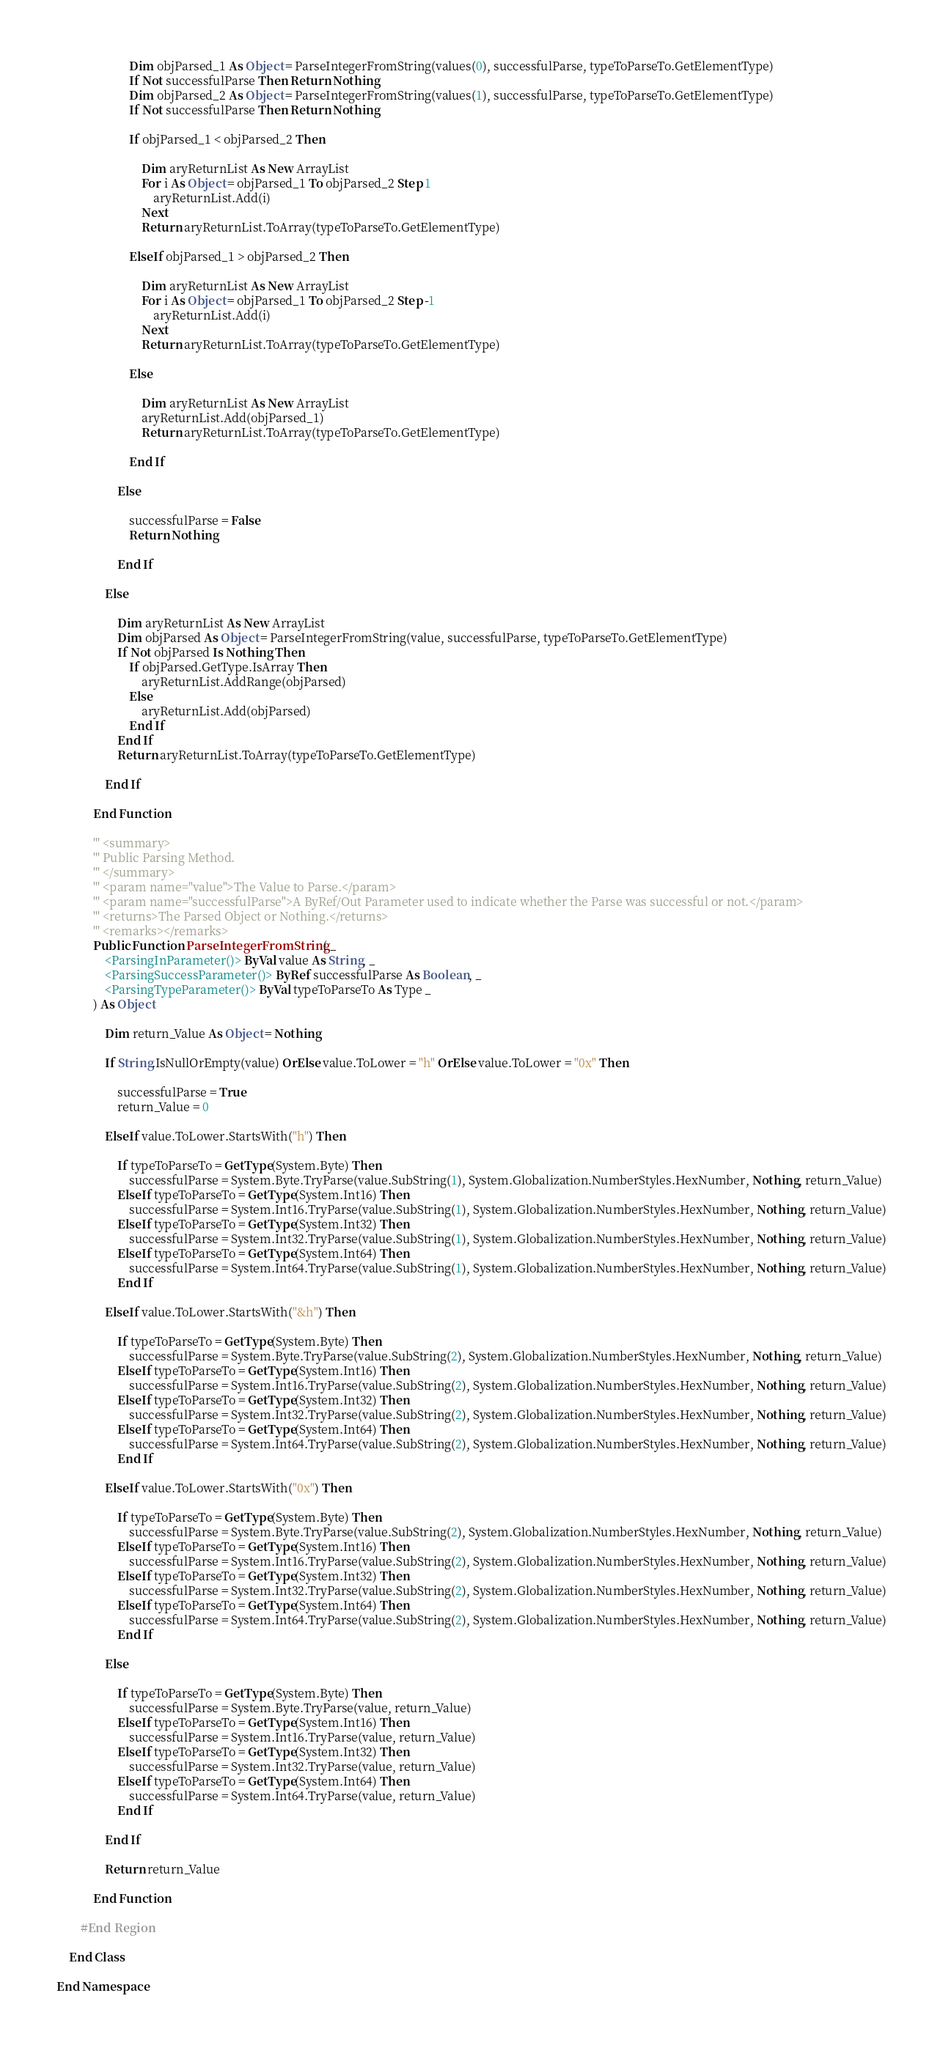<code> <loc_0><loc_0><loc_500><loc_500><_VisualBasic_>
						Dim objParsed_1 As Object = ParseIntegerFromString(values(0), successfulParse, typeToParseTo.GetElementType)
						If Not successfulParse Then Return Nothing
						Dim objParsed_2 As Object = ParseIntegerFromString(values(1), successfulParse, typeToParseTo.GetElementType)
						If Not successfulParse Then Return Nothing

						If objParsed_1 < objParsed_2 Then

							Dim aryReturnList As New ArrayList
							For i As Object = objParsed_1 To objParsed_2 Step 1
								aryReturnList.Add(i)
							Next
							Return aryReturnList.ToArray(typeToParseTo.GetElementType)

						ElseIf objParsed_1 > objParsed_2 Then

							Dim aryReturnList As New ArrayList
							For i As Object = objParsed_1 To objParsed_2 Step -1
								aryReturnList.Add(i)
							Next
							Return aryReturnList.ToArray(typeToParseTo.GetElementType)

						Else

							Dim aryReturnList As New ArrayList
							aryReturnList.Add(objParsed_1)
							Return aryReturnList.ToArray(typeToParseTo.GetElementType)

						End If

					Else

						successfulParse = False
						Return Nothing

					End If

				Else

					Dim aryReturnList As New ArrayList
					Dim objParsed As Object = ParseIntegerFromString(value, successfulParse, typeToParseTo.GetElementType)
					If Not objParsed Is Nothing Then
						If objParsed.GetType.IsArray Then
							aryReturnList.AddRange(objParsed)
						Else
							aryReturnList.Add(objParsed)
						End If
					End If
					Return aryReturnList.ToArray(typeToParseTo.GetElementType)

				End If

			End Function

			''' <summary>
			''' Public Parsing Method.
			''' </summary>
			''' <param name="value">The Value to Parse.</param>
			''' <param name="successfulParse">A ByRef/Out Parameter used to indicate whether the Parse was successful or not.</param>
			''' <returns>The Parsed Object or Nothing.</returns>
			''' <remarks></remarks>
			Public Function ParseIntegerFromString( _
				<ParsingInParameter()> ByVal value As String, _
				<ParsingSuccessParameter()> ByRef successfulParse As Boolean, _
				<ParsingTypeParameter()> ByVal typeToParseTo As Type _
			) As Object

				Dim return_Value As Object = Nothing

				If String.IsNullOrEmpty(value) OrElse value.ToLower = "h" OrElse value.ToLower = "0x" Then

					successfulParse = True
					return_Value = 0

				ElseIf value.ToLower.StartsWith("h") Then

					If typeToParseTo = GetType(System.Byte) Then
						successfulParse = System.Byte.TryParse(value.SubString(1), System.Globalization.NumberStyles.HexNumber, Nothing, return_Value)
					ElseIf typeToParseTo = GetType(System.Int16) Then
						successfulParse = System.Int16.TryParse(value.SubString(1), System.Globalization.NumberStyles.HexNumber, Nothing, return_Value)
					ElseIf typeToParseTo = GetType(System.Int32) Then
						successfulParse = System.Int32.TryParse(value.SubString(1), System.Globalization.NumberStyles.HexNumber, Nothing, return_Value)
					ElseIf typeToParseTo = GetType(System.Int64) Then
						successfulParse = System.Int64.TryParse(value.SubString(1), System.Globalization.NumberStyles.HexNumber, Nothing, return_Value)
					End If

				ElseIf value.ToLower.StartsWith("&h") Then

					If typeToParseTo = GetType(System.Byte) Then
						successfulParse = System.Byte.TryParse(value.SubString(2), System.Globalization.NumberStyles.HexNumber, Nothing, return_Value)
					ElseIf typeToParseTo = GetType(System.Int16) Then
						successfulParse = System.Int16.TryParse(value.SubString(2), System.Globalization.NumberStyles.HexNumber, Nothing, return_Value)
					ElseIf typeToParseTo = GetType(System.Int32) Then
						successfulParse = System.Int32.TryParse(value.SubString(2), System.Globalization.NumberStyles.HexNumber, Nothing, return_Value)
					ElseIf typeToParseTo = GetType(System.Int64) Then
						successfulParse = System.Int64.TryParse(value.SubString(2), System.Globalization.NumberStyles.HexNumber, Nothing, return_Value)
					End If

				ElseIf value.ToLower.StartsWith("0x") Then

					If typeToParseTo = GetType(System.Byte) Then
						successfulParse = System.Byte.TryParse(value.SubString(2), System.Globalization.NumberStyles.HexNumber, Nothing, return_Value)
					ElseIf typeToParseTo = GetType(System.Int16) Then
						successfulParse = System.Int16.TryParse(value.SubString(2), System.Globalization.NumberStyles.HexNumber, Nothing, return_Value)
					ElseIf typeToParseTo = GetType(System.Int32) Then
						successfulParse = System.Int32.TryParse(value.SubString(2), System.Globalization.NumberStyles.HexNumber, Nothing, return_Value)
					ElseIf typeToParseTo = GetType(System.Int64) Then
						successfulParse = System.Int64.TryParse(value.SubString(2), System.Globalization.NumberStyles.HexNumber, Nothing, return_Value)
					End If

				Else

					If typeToParseTo = GetType(System.Byte) Then
						successfulParse = System.Byte.TryParse(value, return_Value)
					ElseIf typeToParseTo = GetType(System.Int16) Then
						successfulParse = System.Int16.TryParse(value, return_Value)
					ElseIf typeToParseTo = GetType(System.Int32) Then
						successfulParse = System.Int32.TryParse(value, return_Value)
					ElseIf typeToParseTo = GetType(System.Int64) Then
						successfulParse = System.Int64.TryParse(value, return_Value)
					End If

				End If

				Return return_Value

			End Function

		#End Region

	End Class

End Namespace
</code> 